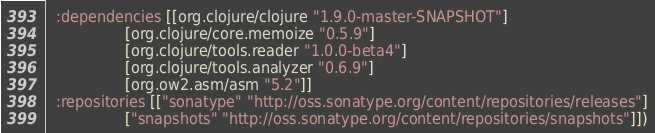<code> <loc_0><loc_0><loc_500><loc_500><_Clojure_>  :dependencies [[org.clojure/clojure "1.9.0-master-SNAPSHOT"]
                 [org.clojure/core.memoize "0.5.9"]
                 [org.clojure/tools.reader "1.0.0-beta4"]
                 [org.clojure/tools.analyzer "0.6.9"]
                 [org.ow2.asm/asm "5.2"]]
  :repositories [["sonatype" "http://oss.sonatype.org/content/repositories/releases"]
                 ["snapshots" "http://oss.sonatype.org/content/repositories/snapshots"]])
</code> 